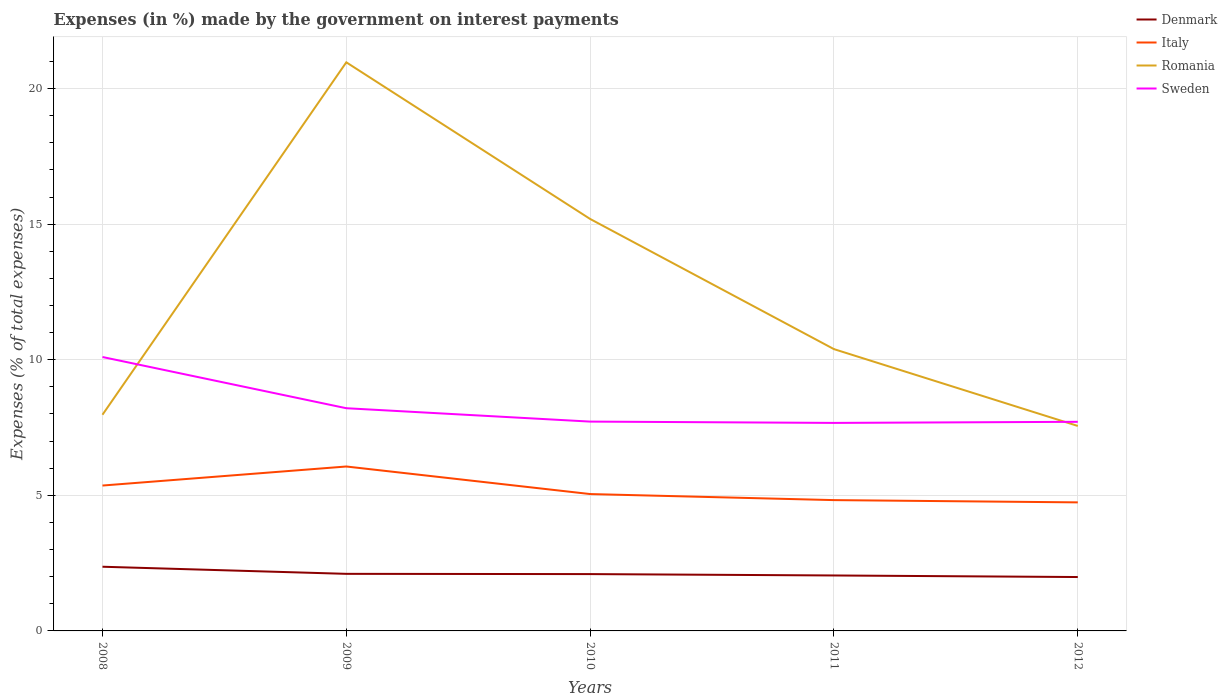Is the number of lines equal to the number of legend labels?
Give a very brief answer. Yes. Across all years, what is the maximum percentage of expenses made by the government on interest payments in Sweden?
Offer a terse response. 7.67. In which year was the percentage of expenses made by the government on interest payments in Italy maximum?
Keep it short and to the point. 2012. What is the total percentage of expenses made by the government on interest payments in Denmark in the graph?
Keep it short and to the point. 0.06. What is the difference between the highest and the second highest percentage of expenses made by the government on interest payments in Sweden?
Give a very brief answer. 2.43. What is the difference between two consecutive major ticks on the Y-axis?
Provide a succinct answer. 5. Does the graph contain grids?
Ensure brevity in your answer.  Yes. Where does the legend appear in the graph?
Make the answer very short. Top right. What is the title of the graph?
Ensure brevity in your answer.  Expenses (in %) made by the government on interest payments. Does "Least developed countries" appear as one of the legend labels in the graph?
Offer a very short reply. No. What is the label or title of the Y-axis?
Ensure brevity in your answer.  Expenses (% of total expenses). What is the Expenses (% of total expenses) of Denmark in 2008?
Keep it short and to the point. 2.37. What is the Expenses (% of total expenses) in Italy in 2008?
Offer a very short reply. 5.36. What is the Expenses (% of total expenses) in Romania in 2008?
Make the answer very short. 7.97. What is the Expenses (% of total expenses) in Sweden in 2008?
Give a very brief answer. 10.1. What is the Expenses (% of total expenses) of Denmark in 2009?
Keep it short and to the point. 2.1. What is the Expenses (% of total expenses) in Italy in 2009?
Offer a terse response. 6.06. What is the Expenses (% of total expenses) in Romania in 2009?
Make the answer very short. 20.97. What is the Expenses (% of total expenses) of Sweden in 2009?
Give a very brief answer. 8.21. What is the Expenses (% of total expenses) of Denmark in 2010?
Provide a succinct answer. 2.1. What is the Expenses (% of total expenses) in Italy in 2010?
Offer a very short reply. 5.05. What is the Expenses (% of total expenses) in Romania in 2010?
Provide a succinct answer. 15.19. What is the Expenses (% of total expenses) of Sweden in 2010?
Offer a terse response. 7.72. What is the Expenses (% of total expenses) in Denmark in 2011?
Keep it short and to the point. 2.04. What is the Expenses (% of total expenses) in Italy in 2011?
Your answer should be compact. 4.82. What is the Expenses (% of total expenses) in Romania in 2011?
Provide a short and direct response. 10.39. What is the Expenses (% of total expenses) in Sweden in 2011?
Provide a succinct answer. 7.67. What is the Expenses (% of total expenses) of Denmark in 2012?
Give a very brief answer. 1.99. What is the Expenses (% of total expenses) in Italy in 2012?
Ensure brevity in your answer.  4.74. What is the Expenses (% of total expenses) of Romania in 2012?
Provide a short and direct response. 7.56. What is the Expenses (% of total expenses) in Sweden in 2012?
Keep it short and to the point. 7.71. Across all years, what is the maximum Expenses (% of total expenses) of Denmark?
Give a very brief answer. 2.37. Across all years, what is the maximum Expenses (% of total expenses) in Italy?
Your response must be concise. 6.06. Across all years, what is the maximum Expenses (% of total expenses) in Romania?
Give a very brief answer. 20.97. Across all years, what is the maximum Expenses (% of total expenses) of Sweden?
Offer a terse response. 10.1. Across all years, what is the minimum Expenses (% of total expenses) in Denmark?
Provide a succinct answer. 1.99. Across all years, what is the minimum Expenses (% of total expenses) of Italy?
Provide a succinct answer. 4.74. Across all years, what is the minimum Expenses (% of total expenses) of Romania?
Your response must be concise. 7.56. Across all years, what is the minimum Expenses (% of total expenses) in Sweden?
Make the answer very short. 7.67. What is the total Expenses (% of total expenses) of Denmark in the graph?
Offer a terse response. 10.6. What is the total Expenses (% of total expenses) of Italy in the graph?
Provide a short and direct response. 26.03. What is the total Expenses (% of total expenses) in Romania in the graph?
Provide a short and direct response. 62.08. What is the total Expenses (% of total expenses) in Sweden in the graph?
Offer a terse response. 41.41. What is the difference between the Expenses (% of total expenses) in Denmark in 2008 and that in 2009?
Provide a succinct answer. 0.26. What is the difference between the Expenses (% of total expenses) of Italy in 2008 and that in 2009?
Provide a succinct answer. -0.7. What is the difference between the Expenses (% of total expenses) of Romania in 2008 and that in 2009?
Your answer should be very brief. -13. What is the difference between the Expenses (% of total expenses) of Sweden in 2008 and that in 2009?
Your answer should be very brief. 1.89. What is the difference between the Expenses (% of total expenses) of Denmark in 2008 and that in 2010?
Make the answer very short. 0.27. What is the difference between the Expenses (% of total expenses) in Italy in 2008 and that in 2010?
Ensure brevity in your answer.  0.31. What is the difference between the Expenses (% of total expenses) of Romania in 2008 and that in 2010?
Make the answer very short. -7.22. What is the difference between the Expenses (% of total expenses) of Sweden in 2008 and that in 2010?
Keep it short and to the point. 2.38. What is the difference between the Expenses (% of total expenses) in Denmark in 2008 and that in 2011?
Offer a very short reply. 0.32. What is the difference between the Expenses (% of total expenses) of Italy in 2008 and that in 2011?
Ensure brevity in your answer.  0.54. What is the difference between the Expenses (% of total expenses) of Romania in 2008 and that in 2011?
Your answer should be very brief. -2.42. What is the difference between the Expenses (% of total expenses) of Sweden in 2008 and that in 2011?
Give a very brief answer. 2.43. What is the difference between the Expenses (% of total expenses) of Denmark in 2008 and that in 2012?
Provide a succinct answer. 0.38. What is the difference between the Expenses (% of total expenses) of Italy in 2008 and that in 2012?
Your answer should be very brief. 0.62. What is the difference between the Expenses (% of total expenses) of Romania in 2008 and that in 2012?
Your response must be concise. 0.41. What is the difference between the Expenses (% of total expenses) in Sweden in 2008 and that in 2012?
Make the answer very short. 2.39. What is the difference between the Expenses (% of total expenses) of Denmark in 2009 and that in 2010?
Offer a terse response. 0.01. What is the difference between the Expenses (% of total expenses) of Italy in 2009 and that in 2010?
Offer a terse response. 1.02. What is the difference between the Expenses (% of total expenses) in Romania in 2009 and that in 2010?
Your answer should be compact. 5.78. What is the difference between the Expenses (% of total expenses) in Sweden in 2009 and that in 2010?
Your answer should be compact. 0.49. What is the difference between the Expenses (% of total expenses) of Denmark in 2009 and that in 2011?
Keep it short and to the point. 0.06. What is the difference between the Expenses (% of total expenses) of Italy in 2009 and that in 2011?
Your answer should be very brief. 1.24. What is the difference between the Expenses (% of total expenses) of Romania in 2009 and that in 2011?
Provide a succinct answer. 10.58. What is the difference between the Expenses (% of total expenses) of Sweden in 2009 and that in 2011?
Keep it short and to the point. 0.54. What is the difference between the Expenses (% of total expenses) of Denmark in 2009 and that in 2012?
Keep it short and to the point. 0.12. What is the difference between the Expenses (% of total expenses) of Italy in 2009 and that in 2012?
Provide a succinct answer. 1.32. What is the difference between the Expenses (% of total expenses) in Romania in 2009 and that in 2012?
Your answer should be compact. 13.41. What is the difference between the Expenses (% of total expenses) in Sweden in 2009 and that in 2012?
Give a very brief answer. 0.5. What is the difference between the Expenses (% of total expenses) of Denmark in 2010 and that in 2011?
Keep it short and to the point. 0.05. What is the difference between the Expenses (% of total expenses) in Italy in 2010 and that in 2011?
Provide a short and direct response. 0.22. What is the difference between the Expenses (% of total expenses) of Romania in 2010 and that in 2011?
Ensure brevity in your answer.  4.8. What is the difference between the Expenses (% of total expenses) in Sweden in 2010 and that in 2011?
Keep it short and to the point. 0.05. What is the difference between the Expenses (% of total expenses) in Denmark in 2010 and that in 2012?
Your answer should be compact. 0.11. What is the difference between the Expenses (% of total expenses) in Italy in 2010 and that in 2012?
Your answer should be very brief. 0.31. What is the difference between the Expenses (% of total expenses) in Romania in 2010 and that in 2012?
Provide a short and direct response. 7.63. What is the difference between the Expenses (% of total expenses) of Sweden in 2010 and that in 2012?
Offer a terse response. 0.01. What is the difference between the Expenses (% of total expenses) of Denmark in 2011 and that in 2012?
Your response must be concise. 0.06. What is the difference between the Expenses (% of total expenses) in Italy in 2011 and that in 2012?
Keep it short and to the point. 0.08. What is the difference between the Expenses (% of total expenses) in Romania in 2011 and that in 2012?
Your response must be concise. 2.83. What is the difference between the Expenses (% of total expenses) in Sweden in 2011 and that in 2012?
Keep it short and to the point. -0.04. What is the difference between the Expenses (% of total expenses) of Denmark in 2008 and the Expenses (% of total expenses) of Italy in 2009?
Provide a succinct answer. -3.7. What is the difference between the Expenses (% of total expenses) of Denmark in 2008 and the Expenses (% of total expenses) of Romania in 2009?
Ensure brevity in your answer.  -18.6. What is the difference between the Expenses (% of total expenses) of Denmark in 2008 and the Expenses (% of total expenses) of Sweden in 2009?
Provide a succinct answer. -5.85. What is the difference between the Expenses (% of total expenses) of Italy in 2008 and the Expenses (% of total expenses) of Romania in 2009?
Give a very brief answer. -15.61. What is the difference between the Expenses (% of total expenses) in Italy in 2008 and the Expenses (% of total expenses) in Sweden in 2009?
Keep it short and to the point. -2.85. What is the difference between the Expenses (% of total expenses) of Romania in 2008 and the Expenses (% of total expenses) of Sweden in 2009?
Keep it short and to the point. -0.24. What is the difference between the Expenses (% of total expenses) in Denmark in 2008 and the Expenses (% of total expenses) in Italy in 2010?
Your answer should be compact. -2.68. What is the difference between the Expenses (% of total expenses) in Denmark in 2008 and the Expenses (% of total expenses) in Romania in 2010?
Give a very brief answer. -12.82. What is the difference between the Expenses (% of total expenses) of Denmark in 2008 and the Expenses (% of total expenses) of Sweden in 2010?
Offer a very short reply. -5.35. What is the difference between the Expenses (% of total expenses) in Italy in 2008 and the Expenses (% of total expenses) in Romania in 2010?
Keep it short and to the point. -9.83. What is the difference between the Expenses (% of total expenses) of Italy in 2008 and the Expenses (% of total expenses) of Sweden in 2010?
Your answer should be compact. -2.36. What is the difference between the Expenses (% of total expenses) in Romania in 2008 and the Expenses (% of total expenses) in Sweden in 2010?
Make the answer very short. 0.25. What is the difference between the Expenses (% of total expenses) in Denmark in 2008 and the Expenses (% of total expenses) in Italy in 2011?
Make the answer very short. -2.46. What is the difference between the Expenses (% of total expenses) of Denmark in 2008 and the Expenses (% of total expenses) of Romania in 2011?
Ensure brevity in your answer.  -8.02. What is the difference between the Expenses (% of total expenses) of Denmark in 2008 and the Expenses (% of total expenses) of Sweden in 2011?
Give a very brief answer. -5.3. What is the difference between the Expenses (% of total expenses) in Italy in 2008 and the Expenses (% of total expenses) in Romania in 2011?
Make the answer very short. -5.03. What is the difference between the Expenses (% of total expenses) in Italy in 2008 and the Expenses (% of total expenses) in Sweden in 2011?
Your answer should be compact. -2.31. What is the difference between the Expenses (% of total expenses) of Romania in 2008 and the Expenses (% of total expenses) of Sweden in 2011?
Your answer should be very brief. 0.3. What is the difference between the Expenses (% of total expenses) of Denmark in 2008 and the Expenses (% of total expenses) of Italy in 2012?
Make the answer very short. -2.37. What is the difference between the Expenses (% of total expenses) in Denmark in 2008 and the Expenses (% of total expenses) in Romania in 2012?
Ensure brevity in your answer.  -5.19. What is the difference between the Expenses (% of total expenses) of Denmark in 2008 and the Expenses (% of total expenses) of Sweden in 2012?
Your answer should be compact. -5.34. What is the difference between the Expenses (% of total expenses) in Italy in 2008 and the Expenses (% of total expenses) in Romania in 2012?
Provide a succinct answer. -2.2. What is the difference between the Expenses (% of total expenses) of Italy in 2008 and the Expenses (% of total expenses) of Sweden in 2012?
Keep it short and to the point. -2.35. What is the difference between the Expenses (% of total expenses) in Romania in 2008 and the Expenses (% of total expenses) in Sweden in 2012?
Offer a terse response. 0.26. What is the difference between the Expenses (% of total expenses) in Denmark in 2009 and the Expenses (% of total expenses) in Italy in 2010?
Provide a short and direct response. -2.94. What is the difference between the Expenses (% of total expenses) in Denmark in 2009 and the Expenses (% of total expenses) in Romania in 2010?
Your answer should be compact. -13.09. What is the difference between the Expenses (% of total expenses) of Denmark in 2009 and the Expenses (% of total expenses) of Sweden in 2010?
Give a very brief answer. -5.61. What is the difference between the Expenses (% of total expenses) in Italy in 2009 and the Expenses (% of total expenses) in Romania in 2010?
Keep it short and to the point. -9.13. What is the difference between the Expenses (% of total expenses) of Italy in 2009 and the Expenses (% of total expenses) of Sweden in 2010?
Keep it short and to the point. -1.66. What is the difference between the Expenses (% of total expenses) in Romania in 2009 and the Expenses (% of total expenses) in Sweden in 2010?
Provide a short and direct response. 13.25. What is the difference between the Expenses (% of total expenses) in Denmark in 2009 and the Expenses (% of total expenses) in Italy in 2011?
Provide a short and direct response. -2.72. What is the difference between the Expenses (% of total expenses) in Denmark in 2009 and the Expenses (% of total expenses) in Romania in 2011?
Make the answer very short. -8.29. What is the difference between the Expenses (% of total expenses) of Denmark in 2009 and the Expenses (% of total expenses) of Sweden in 2011?
Provide a succinct answer. -5.57. What is the difference between the Expenses (% of total expenses) in Italy in 2009 and the Expenses (% of total expenses) in Romania in 2011?
Ensure brevity in your answer.  -4.33. What is the difference between the Expenses (% of total expenses) in Italy in 2009 and the Expenses (% of total expenses) in Sweden in 2011?
Ensure brevity in your answer.  -1.61. What is the difference between the Expenses (% of total expenses) in Romania in 2009 and the Expenses (% of total expenses) in Sweden in 2011?
Ensure brevity in your answer.  13.3. What is the difference between the Expenses (% of total expenses) in Denmark in 2009 and the Expenses (% of total expenses) in Italy in 2012?
Provide a succinct answer. -2.64. What is the difference between the Expenses (% of total expenses) in Denmark in 2009 and the Expenses (% of total expenses) in Romania in 2012?
Keep it short and to the point. -5.45. What is the difference between the Expenses (% of total expenses) in Denmark in 2009 and the Expenses (% of total expenses) in Sweden in 2012?
Give a very brief answer. -5.61. What is the difference between the Expenses (% of total expenses) in Italy in 2009 and the Expenses (% of total expenses) in Romania in 2012?
Offer a very short reply. -1.5. What is the difference between the Expenses (% of total expenses) of Italy in 2009 and the Expenses (% of total expenses) of Sweden in 2012?
Offer a terse response. -1.65. What is the difference between the Expenses (% of total expenses) in Romania in 2009 and the Expenses (% of total expenses) in Sweden in 2012?
Provide a short and direct response. 13.26. What is the difference between the Expenses (% of total expenses) in Denmark in 2010 and the Expenses (% of total expenses) in Italy in 2011?
Make the answer very short. -2.73. What is the difference between the Expenses (% of total expenses) of Denmark in 2010 and the Expenses (% of total expenses) of Romania in 2011?
Offer a very short reply. -8.3. What is the difference between the Expenses (% of total expenses) in Denmark in 2010 and the Expenses (% of total expenses) in Sweden in 2011?
Ensure brevity in your answer.  -5.58. What is the difference between the Expenses (% of total expenses) in Italy in 2010 and the Expenses (% of total expenses) in Romania in 2011?
Provide a short and direct response. -5.34. What is the difference between the Expenses (% of total expenses) of Italy in 2010 and the Expenses (% of total expenses) of Sweden in 2011?
Keep it short and to the point. -2.62. What is the difference between the Expenses (% of total expenses) in Romania in 2010 and the Expenses (% of total expenses) in Sweden in 2011?
Offer a very short reply. 7.52. What is the difference between the Expenses (% of total expenses) in Denmark in 2010 and the Expenses (% of total expenses) in Italy in 2012?
Ensure brevity in your answer.  -2.64. What is the difference between the Expenses (% of total expenses) of Denmark in 2010 and the Expenses (% of total expenses) of Romania in 2012?
Ensure brevity in your answer.  -5.46. What is the difference between the Expenses (% of total expenses) of Denmark in 2010 and the Expenses (% of total expenses) of Sweden in 2012?
Give a very brief answer. -5.62. What is the difference between the Expenses (% of total expenses) of Italy in 2010 and the Expenses (% of total expenses) of Romania in 2012?
Your answer should be compact. -2.51. What is the difference between the Expenses (% of total expenses) in Italy in 2010 and the Expenses (% of total expenses) in Sweden in 2012?
Your response must be concise. -2.66. What is the difference between the Expenses (% of total expenses) of Romania in 2010 and the Expenses (% of total expenses) of Sweden in 2012?
Your answer should be very brief. 7.48. What is the difference between the Expenses (% of total expenses) of Denmark in 2011 and the Expenses (% of total expenses) of Italy in 2012?
Offer a terse response. -2.7. What is the difference between the Expenses (% of total expenses) of Denmark in 2011 and the Expenses (% of total expenses) of Romania in 2012?
Offer a terse response. -5.51. What is the difference between the Expenses (% of total expenses) of Denmark in 2011 and the Expenses (% of total expenses) of Sweden in 2012?
Make the answer very short. -5.67. What is the difference between the Expenses (% of total expenses) in Italy in 2011 and the Expenses (% of total expenses) in Romania in 2012?
Make the answer very short. -2.73. What is the difference between the Expenses (% of total expenses) in Italy in 2011 and the Expenses (% of total expenses) in Sweden in 2012?
Your answer should be compact. -2.89. What is the difference between the Expenses (% of total expenses) in Romania in 2011 and the Expenses (% of total expenses) in Sweden in 2012?
Provide a succinct answer. 2.68. What is the average Expenses (% of total expenses) in Denmark per year?
Your response must be concise. 2.12. What is the average Expenses (% of total expenses) of Italy per year?
Offer a very short reply. 5.21. What is the average Expenses (% of total expenses) in Romania per year?
Offer a terse response. 12.42. What is the average Expenses (% of total expenses) in Sweden per year?
Offer a terse response. 8.28. In the year 2008, what is the difference between the Expenses (% of total expenses) in Denmark and Expenses (% of total expenses) in Italy?
Ensure brevity in your answer.  -2.99. In the year 2008, what is the difference between the Expenses (% of total expenses) of Denmark and Expenses (% of total expenses) of Romania?
Your response must be concise. -5.61. In the year 2008, what is the difference between the Expenses (% of total expenses) of Denmark and Expenses (% of total expenses) of Sweden?
Offer a very short reply. -7.73. In the year 2008, what is the difference between the Expenses (% of total expenses) of Italy and Expenses (% of total expenses) of Romania?
Make the answer very short. -2.61. In the year 2008, what is the difference between the Expenses (% of total expenses) in Italy and Expenses (% of total expenses) in Sweden?
Your answer should be very brief. -4.74. In the year 2008, what is the difference between the Expenses (% of total expenses) in Romania and Expenses (% of total expenses) in Sweden?
Keep it short and to the point. -2.13. In the year 2009, what is the difference between the Expenses (% of total expenses) of Denmark and Expenses (% of total expenses) of Italy?
Make the answer very short. -3.96. In the year 2009, what is the difference between the Expenses (% of total expenses) of Denmark and Expenses (% of total expenses) of Romania?
Offer a terse response. -18.86. In the year 2009, what is the difference between the Expenses (% of total expenses) in Denmark and Expenses (% of total expenses) in Sweden?
Provide a short and direct response. -6.11. In the year 2009, what is the difference between the Expenses (% of total expenses) in Italy and Expenses (% of total expenses) in Romania?
Your response must be concise. -14.9. In the year 2009, what is the difference between the Expenses (% of total expenses) in Italy and Expenses (% of total expenses) in Sweden?
Make the answer very short. -2.15. In the year 2009, what is the difference between the Expenses (% of total expenses) in Romania and Expenses (% of total expenses) in Sweden?
Make the answer very short. 12.76. In the year 2010, what is the difference between the Expenses (% of total expenses) of Denmark and Expenses (% of total expenses) of Italy?
Provide a succinct answer. -2.95. In the year 2010, what is the difference between the Expenses (% of total expenses) of Denmark and Expenses (% of total expenses) of Romania?
Ensure brevity in your answer.  -13.1. In the year 2010, what is the difference between the Expenses (% of total expenses) of Denmark and Expenses (% of total expenses) of Sweden?
Your answer should be compact. -5.62. In the year 2010, what is the difference between the Expenses (% of total expenses) of Italy and Expenses (% of total expenses) of Romania?
Ensure brevity in your answer.  -10.14. In the year 2010, what is the difference between the Expenses (% of total expenses) of Italy and Expenses (% of total expenses) of Sweden?
Provide a succinct answer. -2.67. In the year 2010, what is the difference between the Expenses (% of total expenses) of Romania and Expenses (% of total expenses) of Sweden?
Your answer should be compact. 7.47. In the year 2011, what is the difference between the Expenses (% of total expenses) in Denmark and Expenses (% of total expenses) in Italy?
Provide a short and direct response. -2.78. In the year 2011, what is the difference between the Expenses (% of total expenses) in Denmark and Expenses (% of total expenses) in Romania?
Your answer should be very brief. -8.35. In the year 2011, what is the difference between the Expenses (% of total expenses) of Denmark and Expenses (% of total expenses) of Sweden?
Your answer should be compact. -5.63. In the year 2011, what is the difference between the Expenses (% of total expenses) in Italy and Expenses (% of total expenses) in Romania?
Your answer should be very brief. -5.57. In the year 2011, what is the difference between the Expenses (% of total expenses) in Italy and Expenses (% of total expenses) in Sweden?
Keep it short and to the point. -2.85. In the year 2011, what is the difference between the Expenses (% of total expenses) of Romania and Expenses (% of total expenses) of Sweden?
Provide a short and direct response. 2.72. In the year 2012, what is the difference between the Expenses (% of total expenses) of Denmark and Expenses (% of total expenses) of Italy?
Keep it short and to the point. -2.75. In the year 2012, what is the difference between the Expenses (% of total expenses) of Denmark and Expenses (% of total expenses) of Romania?
Offer a very short reply. -5.57. In the year 2012, what is the difference between the Expenses (% of total expenses) in Denmark and Expenses (% of total expenses) in Sweden?
Your answer should be compact. -5.72. In the year 2012, what is the difference between the Expenses (% of total expenses) of Italy and Expenses (% of total expenses) of Romania?
Your answer should be compact. -2.82. In the year 2012, what is the difference between the Expenses (% of total expenses) in Italy and Expenses (% of total expenses) in Sweden?
Keep it short and to the point. -2.97. In the year 2012, what is the difference between the Expenses (% of total expenses) in Romania and Expenses (% of total expenses) in Sweden?
Your answer should be compact. -0.15. What is the ratio of the Expenses (% of total expenses) of Denmark in 2008 to that in 2009?
Provide a succinct answer. 1.12. What is the ratio of the Expenses (% of total expenses) of Italy in 2008 to that in 2009?
Your answer should be very brief. 0.88. What is the ratio of the Expenses (% of total expenses) in Romania in 2008 to that in 2009?
Give a very brief answer. 0.38. What is the ratio of the Expenses (% of total expenses) in Sweden in 2008 to that in 2009?
Your answer should be compact. 1.23. What is the ratio of the Expenses (% of total expenses) of Denmark in 2008 to that in 2010?
Your response must be concise. 1.13. What is the ratio of the Expenses (% of total expenses) of Italy in 2008 to that in 2010?
Provide a succinct answer. 1.06. What is the ratio of the Expenses (% of total expenses) in Romania in 2008 to that in 2010?
Offer a very short reply. 0.52. What is the ratio of the Expenses (% of total expenses) of Sweden in 2008 to that in 2010?
Make the answer very short. 1.31. What is the ratio of the Expenses (% of total expenses) of Denmark in 2008 to that in 2011?
Your answer should be compact. 1.16. What is the ratio of the Expenses (% of total expenses) of Italy in 2008 to that in 2011?
Offer a terse response. 1.11. What is the ratio of the Expenses (% of total expenses) of Romania in 2008 to that in 2011?
Ensure brevity in your answer.  0.77. What is the ratio of the Expenses (% of total expenses) in Sweden in 2008 to that in 2011?
Keep it short and to the point. 1.32. What is the ratio of the Expenses (% of total expenses) in Denmark in 2008 to that in 2012?
Your answer should be compact. 1.19. What is the ratio of the Expenses (% of total expenses) in Italy in 2008 to that in 2012?
Offer a very short reply. 1.13. What is the ratio of the Expenses (% of total expenses) of Romania in 2008 to that in 2012?
Offer a terse response. 1.05. What is the ratio of the Expenses (% of total expenses) in Sweden in 2008 to that in 2012?
Provide a succinct answer. 1.31. What is the ratio of the Expenses (% of total expenses) in Denmark in 2009 to that in 2010?
Your response must be concise. 1. What is the ratio of the Expenses (% of total expenses) in Italy in 2009 to that in 2010?
Make the answer very short. 1.2. What is the ratio of the Expenses (% of total expenses) of Romania in 2009 to that in 2010?
Give a very brief answer. 1.38. What is the ratio of the Expenses (% of total expenses) of Sweden in 2009 to that in 2010?
Give a very brief answer. 1.06. What is the ratio of the Expenses (% of total expenses) in Denmark in 2009 to that in 2011?
Provide a succinct answer. 1.03. What is the ratio of the Expenses (% of total expenses) of Italy in 2009 to that in 2011?
Provide a succinct answer. 1.26. What is the ratio of the Expenses (% of total expenses) of Romania in 2009 to that in 2011?
Offer a terse response. 2.02. What is the ratio of the Expenses (% of total expenses) of Sweden in 2009 to that in 2011?
Keep it short and to the point. 1.07. What is the ratio of the Expenses (% of total expenses) of Denmark in 2009 to that in 2012?
Your answer should be compact. 1.06. What is the ratio of the Expenses (% of total expenses) of Italy in 2009 to that in 2012?
Your response must be concise. 1.28. What is the ratio of the Expenses (% of total expenses) in Romania in 2009 to that in 2012?
Provide a succinct answer. 2.77. What is the ratio of the Expenses (% of total expenses) in Sweden in 2009 to that in 2012?
Your answer should be very brief. 1.06. What is the ratio of the Expenses (% of total expenses) of Denmark in 2010 to that in 2011?
Keep it short and to the point. 1.02. What is the ratio of the Expenses (% of total expenses) in Italy in 2010 to that in 2011?
Keep it short and to the point. 1.05. What is the ratio of the Expenses (% of total expenses) of Romania in 2010 to that in 2011?
Provide a short and direct response. 1.46. What is the ratio of the Expenses (% of total expenses) in Sweden in 2010 to that in 2011?
Provide a succinct answer. 1.01. What is the ratio of the Expenses (% of total expenses) of Denmark in 2010 to that in 2012?
Provide a short and direct response. 1.05. What is the ratio of the Expenses (% of total expenses) in Italy in 2010 to that in 2012?
Offer a terse response. 1.06. What is the ratio of the Expenses (% of total expenses) of Romania in 2010 to that in 2012?
Your response must be concise. 2.01. What is the ratio of the Expenses (% of total expenses) of Sweden in 2010 to that in 2012?
Your response must be concise. 1. What is the ratio of the Expenses (% of total expenses) of Denmark in 2011 to that in 2012?
Offer a terse response. 1.03. What is the ratio of the Expenses (% of total expenses) of Italy in 2011 to that in 2012?
Keep it short and to the point. 1.02. What is the ratio of the Expenses (% of total expenses) of Romania in 2011 to that in 2012?
Your answer should be compact. 1.37. What is the difference between the highest and the second highest Expenses (% of total expenses) of Denmark?
Your answer should be compact. 0.26. What is the difference between the highest and the second highest Expenses (% of total expenses) of Italy?
Your answer should be very brief. 0.7. What is the difference between the highest and the second highest Expenses (% of total expenses) in Romania?
Your answer should be very brief. 5.78. What is the difference between the highest and the second highest Expenses (% of total expenses) of Sweden?
Your answer should be very brief. 1.89. What is the difference between the highest and the lowest Expenses (% of total expenses) of Denmark?
Your answer should be compact. 0.38. What is the difference between the highest and the lowest Expenses (% of total expenses) in Italy?
Offer a terse response. 1.32. What is the difference between the highest and the lowest Expenses (% of total expenses) of Romania?
Your answer should be compact. 13.41. What is the difference between the highest and the lowest Expenses (% of total expenses) of Sweden?
Your answer should be compact. 2.43. 